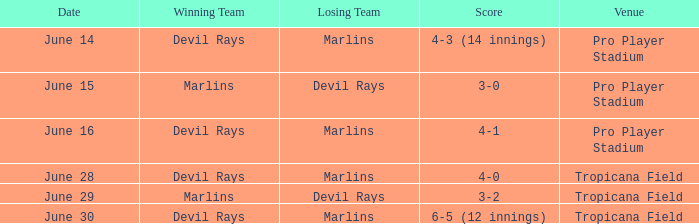When the devil rays experienced a loss on june 29, what was the final score? 3-2. 